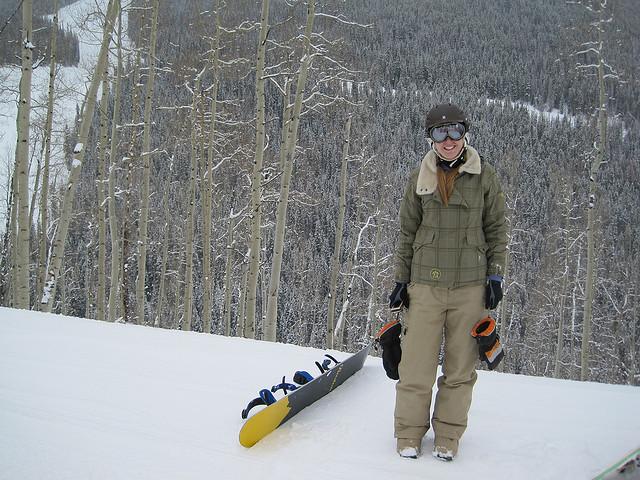What is hanging from his arms?
Concise answer only. Gloves. What kind of hat is this guy wearing?
Answer briefly. Knit. What kind of winter sport is this man doing?
Give a very brief answer. Snowboarding. 